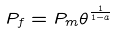<formula> <loc_0><loc_0><loc_500><loc_500>P _ { f } = P _ { m } \theta ^ { \frac { 1 } { 1 - a } }</formula> 